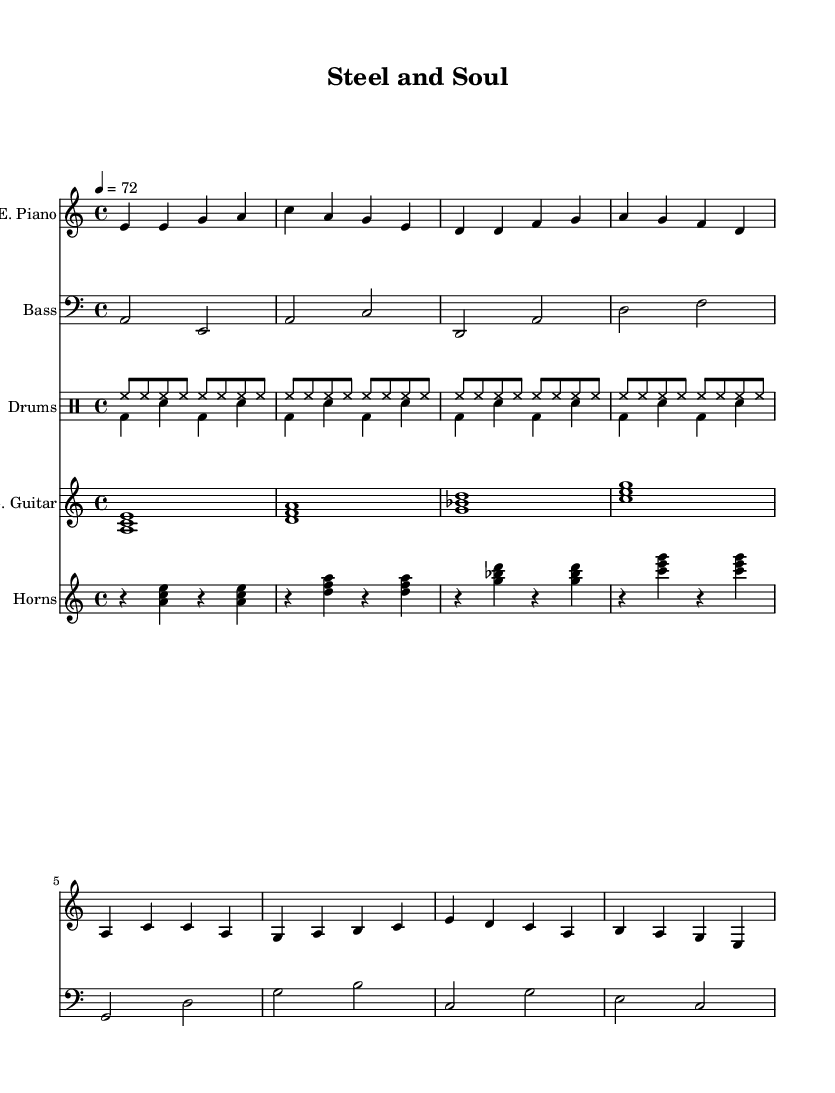What is the key signature of this music? The key signature is indicated by the presence of no sharps or flats, placing it in the key of A minor.
Answer: A minor What is the time signature of this music? The time signature is indicated at the beginning of the score, showing 4/4, which means four beats in each measure and a quarter note receives one beat.
Answer: 4/4 What is the tempo of the piece? The tempo is noted in the score as 4 equals 72, which indicates that there should be 72 quarter note beats per minute.
Answer: 72 How many measures are in the verse? By counting the individual measures in the electric piano part of the verse section, we find there are four measures.
Answer: 4 What instruments are included in the arrangement? The score lists five main staves representing different instruments: Electric Piano, Bass, Drums, Electric Guitar, and Horns.
Answer: Electric Piano, Bass, Drums, Electric Guitar, Horns Which section has a different pattern in the drum parts? Upon examining the score, the drum parts reveal that the Down drumming alternates in a unique pattern with a kick drum and snare, different from the other consistent hihat pattern of the Up section.
Answer: Drums Down Identify the chords used in the electric guitar part. The chords in the electric guitar part are outlined as major triads based on the notes played simultaneously, specifically A minor, D minor, G major, and C major chords.
Answer: A minor, D minor, G major, C major 